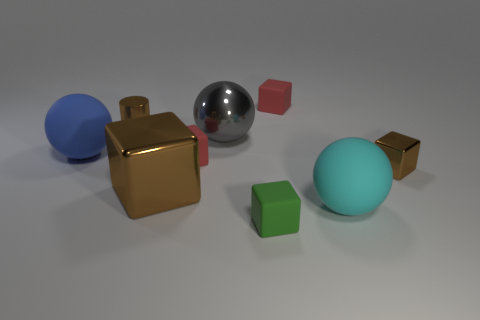Subtract all green blocks. How many blocks are left? 4 Subtract all green rubber cubes. How many cubes are left? 4 Subtract all cyan cubes. Subtract all gray spheres. How many cubes are left? 5 Add 1 small rubber cylinders. How many objects exist? 10 Subtract all blocks. How many objects are left? 4 Add 7 big brown metal things. How many big brown metal things are left? 8 Add 4 purple balls. How many purple balls exist? 4 Subtract 0 blue blocks. How many objects are left? 9 Subtract all small blue matte spheres. Subtract all large blue balls. How many objects are left? 8 